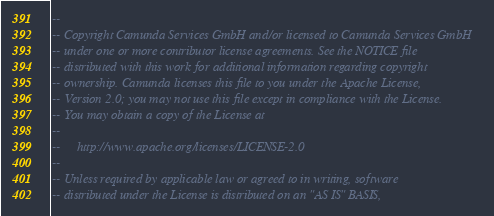Convert code to text. <code><loc_0><loc_0><loc_500><loc_500><_SQL_>--
-- Copyright Camunda Services GmbH and/or licensed to Camunda Services GmbH
-- under one or more contributor license agreements. See the NOTICE file
-- distributed with this work for additional information regarding copyright
-- ownership. Camunda licenses this file to you under the Apache License,
-- Version 2.0; you may not use this file except in compliance with the License.
-- You may obtain a copy of the License at
--
--     http://www.apache.org/licenses/LICENSE-2.0
--
-- Unless required by applicable law or agreed to in writing, software
-- distributed under the License is distributed on an "AS IS" BASIS,</code> 